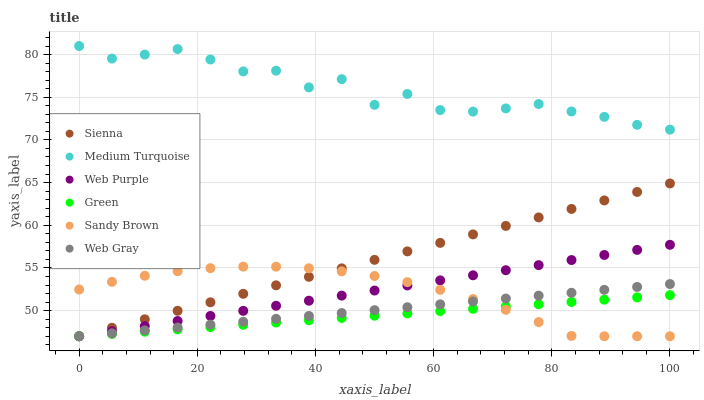Does Green have the minimum area under the curve?
Answer yes or no. Yes. Does Medium Turquoise have the maximum area under the curve?
Answer yes or no. Yes. Does Sienna have the minimum area under the curve?
Answer yes or no. No. Does Sienna have the maximum area under the curve?
Answer yes or no. No. Is Sienna the smoothest?
Answer yes or no. Yes. Is Medium Turquoise the roughest?
Answer yes or no. Yes. Is Web Purple the smoothest?
Answer yes or no. No. Is Web Purple the roughest?
Answer yes or no. No. Does Web Gray have the lowest value?
Answer yes or no. Yes. Does Medium Turquoise have the lowest value?
Answer yes or no. No. Does Medium Turquoise have the highest value?
Answer yes or no. Yes. Does Sienna have the highest value?
Answer yes or no. No. Is Web Purple less than Medium Turquoise?
Answer yes or no. Yes. Is Medium Turquoise greater than Green?
Answer yes or no. Yes. Does Green intersect Web Gray?
Answer yes or no. Yes. Is Green less than Web Gray?
Answer yes or no. No. Is Green greater than Web Gray?
Answer yes or no. No. Does Web Purple intersect Medium Turquoise?
Answer yes or no. No. 